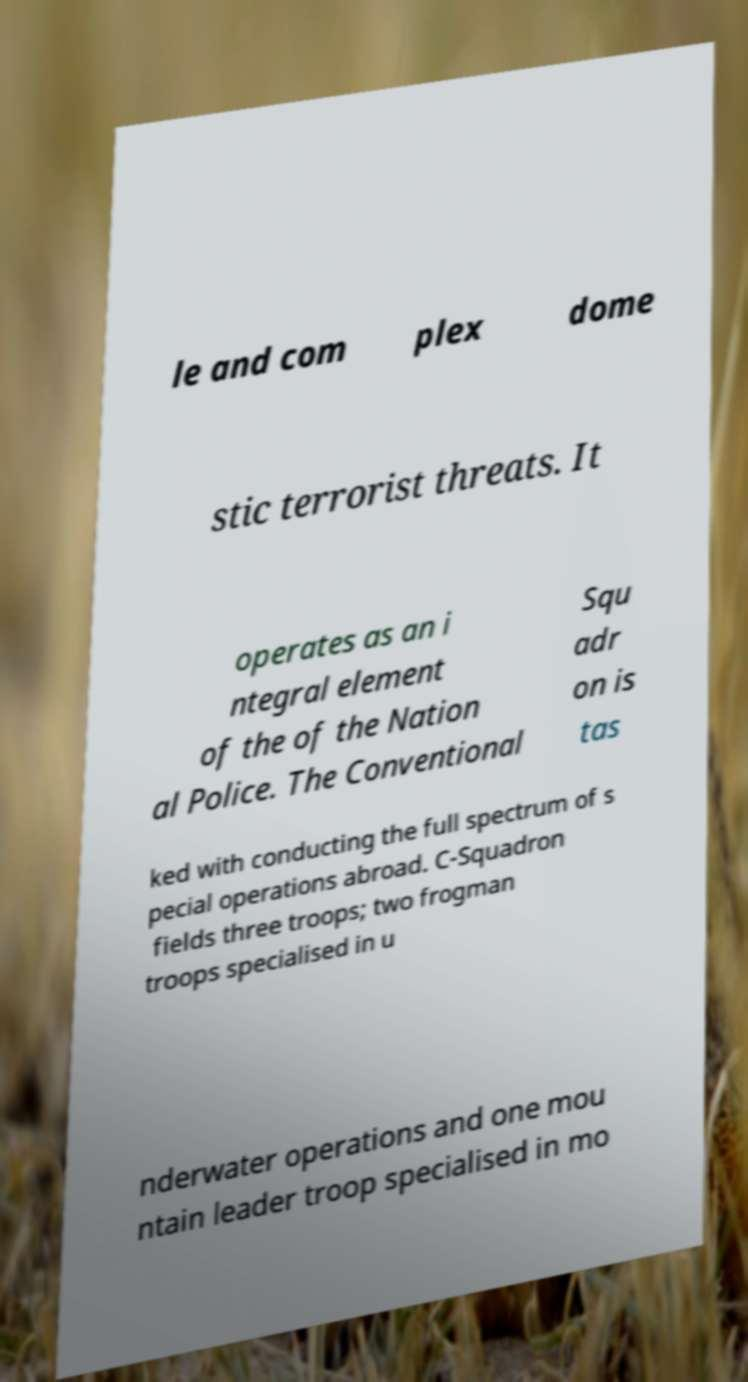Can you read and provide the text displayed in the image?This photo seems to have some interesting text. Can you extract and type it out for me? le and com plex dome stic terrorist threats. It operates as an i ntegral element of the of the Nation al Police. The Conventional Squ adr on is tas ked with conducting the full spectrum of s pecial operations abroad. C-Squadron fields three troops; two frogman troops specialised in u nderwater operations and one mou ntain leader troop specialised in mo 